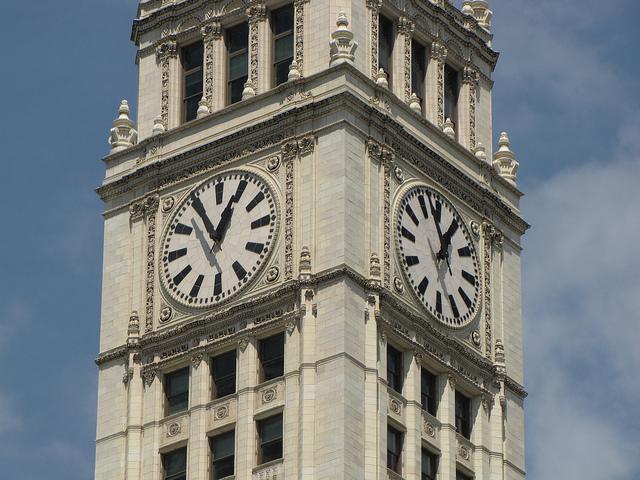How many clocks are there?
Give a very brief answer. 2. 